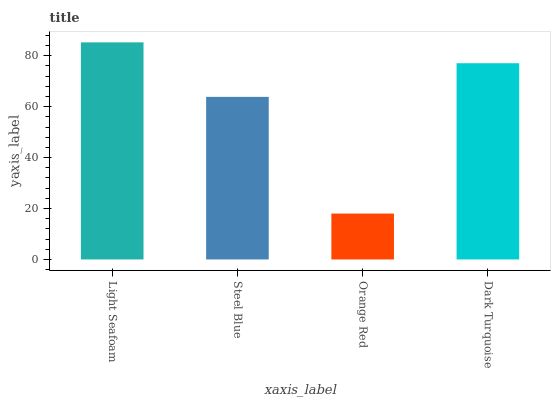Is Orange Red the minimum?
Answer yes or no. Yes. Is Light Seafoam the maximum?
Answer yes or no. Yes. Is Steel Blue the minimum?
Answer yes or no. No. Is Steel Blue the maximum?
Answer yes or no. No. Is Light Seafoam greater than Steel Blue?
Answer yes or no. Yes. Is Steel Blue less than Light Seafoam?
Answer yes or no. Yes. Is Steel Blue greater than Light Seafoam?
Answer yes or no. No. Is Light Seafoam less than Steel Blue?
Answer yes or no. No. Is Dark Turquoise the high median?
Answer yes or no. Yes. Is Steel Blue the low median?
Answer yes or no. Yes. Is Orange Red the high median?
Answer yes or no. No. Is Dark Turquoise the low median?
Answer yes or no. No. 